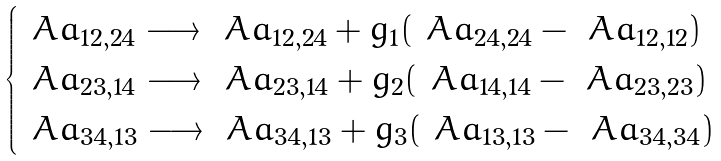<formula> <loc_0><loc_0><loc_500><loc_500>\begin{cases} \ A a _ { 1 2 , 2 4 } \longrightarrow \ A a _ { 1 2 , 2 4 } + g _ { 1 } ( \ A a _ { 2 4 , 2 4 } - \ A a _ { 1 2 , 1 2 } ) \\ \ A a _ { 2 3 , 1 4 } \longrightarrow \ A a _ { 2 3 , 1 4 } + g _ { 2 } ( \ A a _ { 1 4 , 1 4 } - \ A a _ { 2 3 , 2 3 } ) \\ \ A a _ { 3 4 , 1 3 } \longrightarrow \ A a _ { 3 4 , 1 3 } + g _ { 3 } ( \ A a _ { 1 3 , 1 3 } - \ A a _ { 3 4 , 3 4 } ) \end{cases}</formula> 